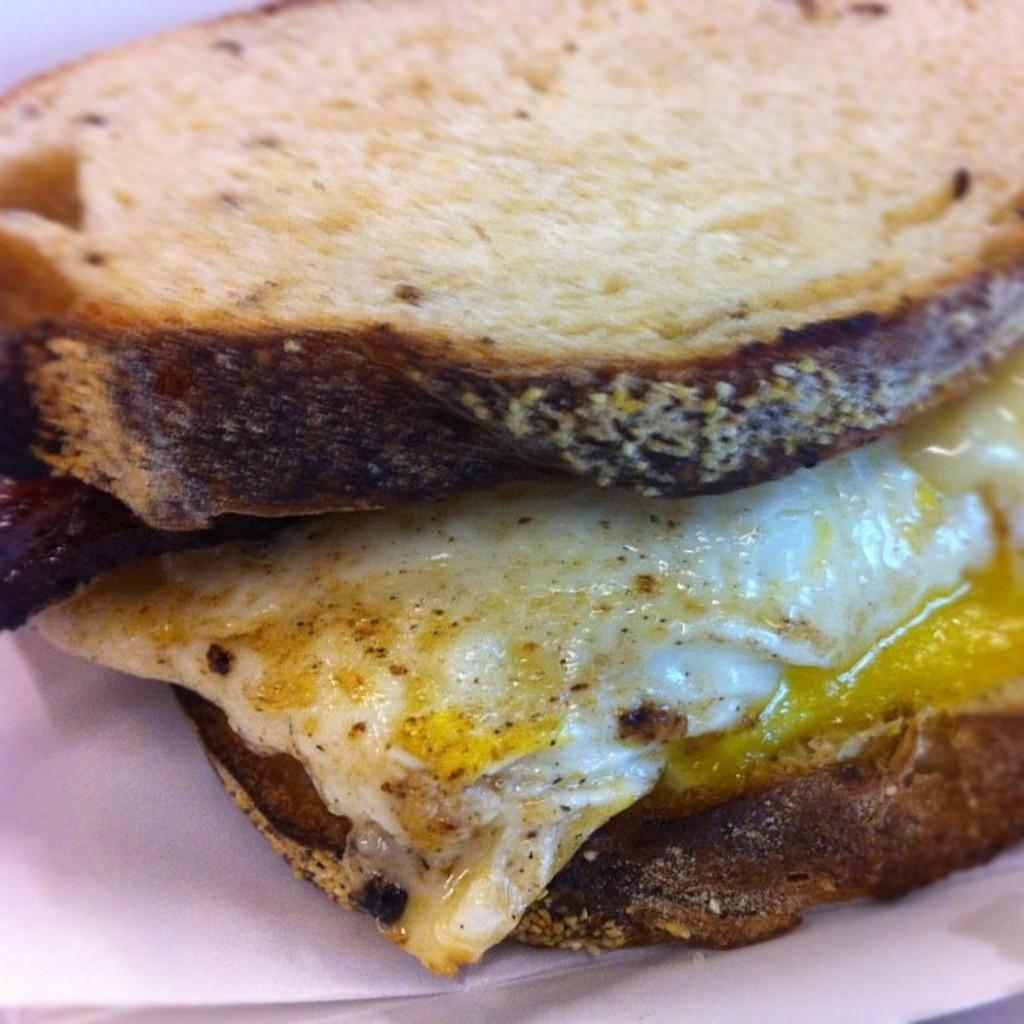What type of food is visible in the image? There is an omelet in the image. How is the omelet presented? The omelet is present between two slices of bread. Where are the omelet and bread located? The omelet and bread are on a plate. What type of leaf is used as a garnish on the omelet in the image? There is no leaf present in the image; it features an omelet between two slices of bread on a plate. 